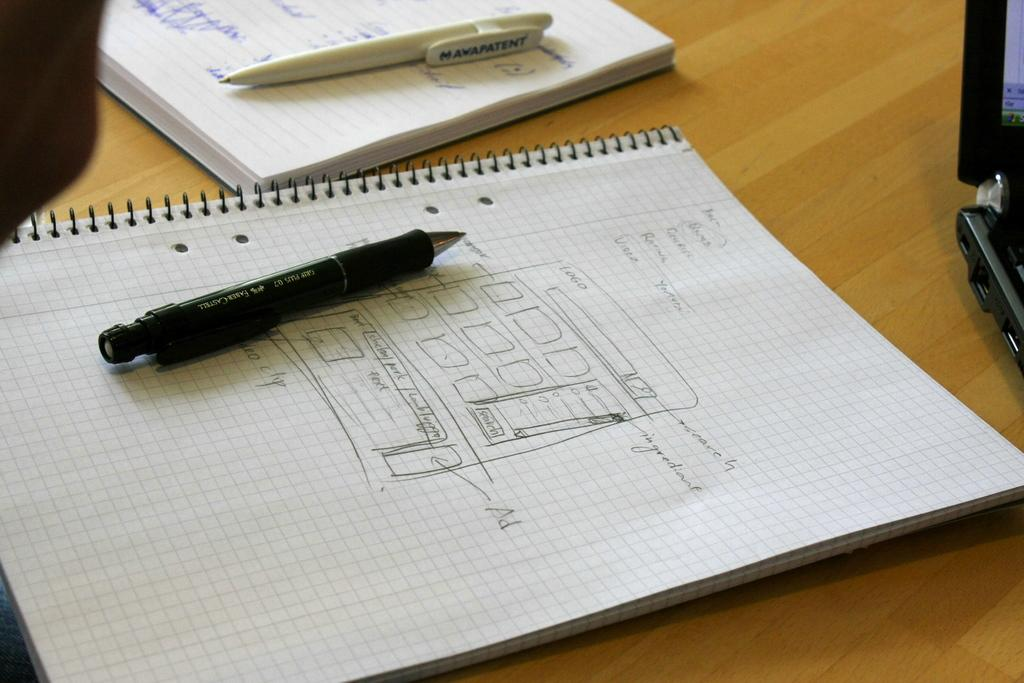What is placed on top of the book in the image? There is a pen on a book in the image. Can you describe the pen in the image? There is a white pen at the top of the image. What type of rifle is resting on the calendar in the image? There is no rifle or calendar present in the image; it only features a pen on a book. 